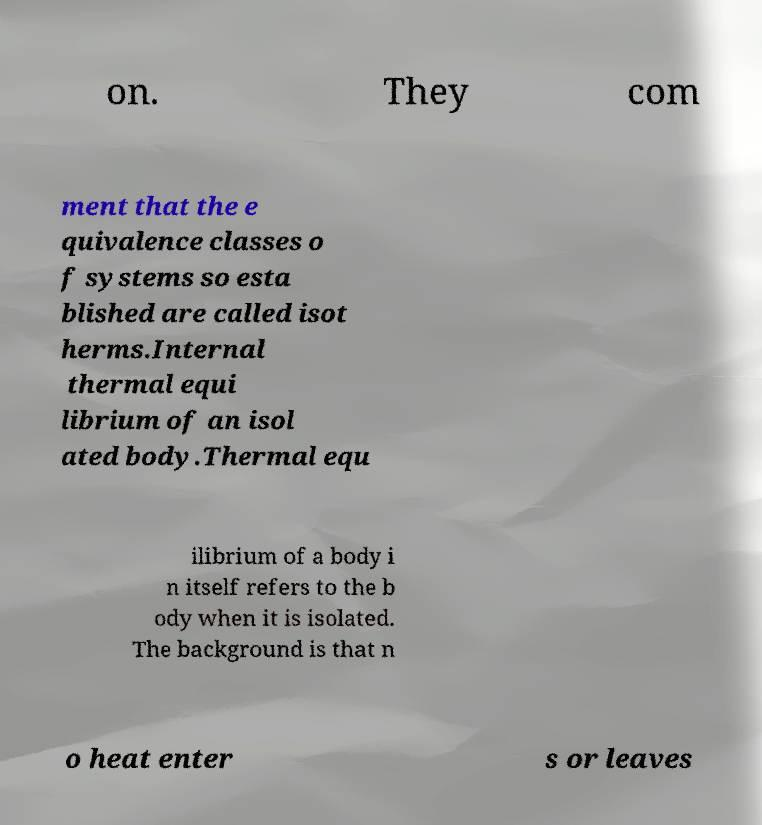Please read and relay the text visible in this image. What does it say? on. They com ment that the e quivalence classes o f systems so esta blished are called isot herms.Internal thermal equi librium of an isol ated body.Thermal equ ilibrium of a body i n itself refers to the b ody when it is isolated. The background is that n o heat enter s or leaves 